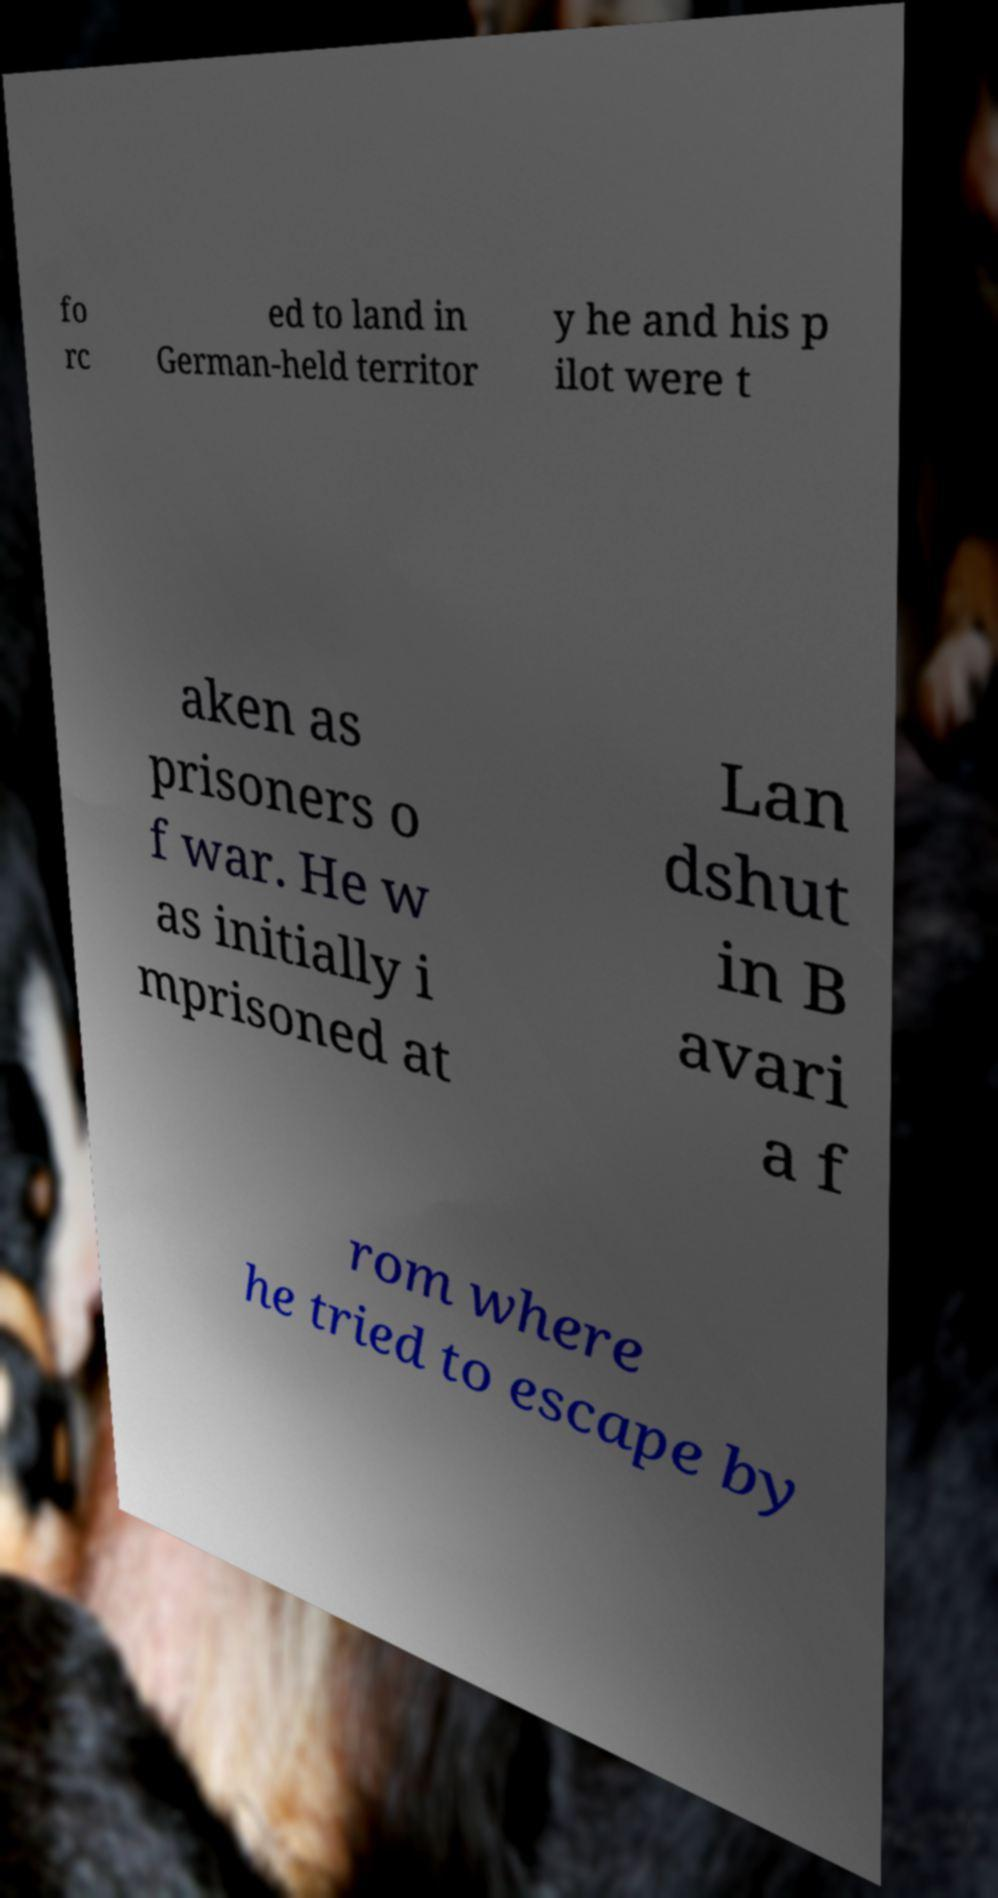Could you assist in decoding the text presented in this image and type it out clearly? fo rc ed to land in German-held territor y he and his p ilot were t aken as prisoners o f war. He w as initially i mprisoned at Lan dshut in B avari a f rom where he tried to escape by 